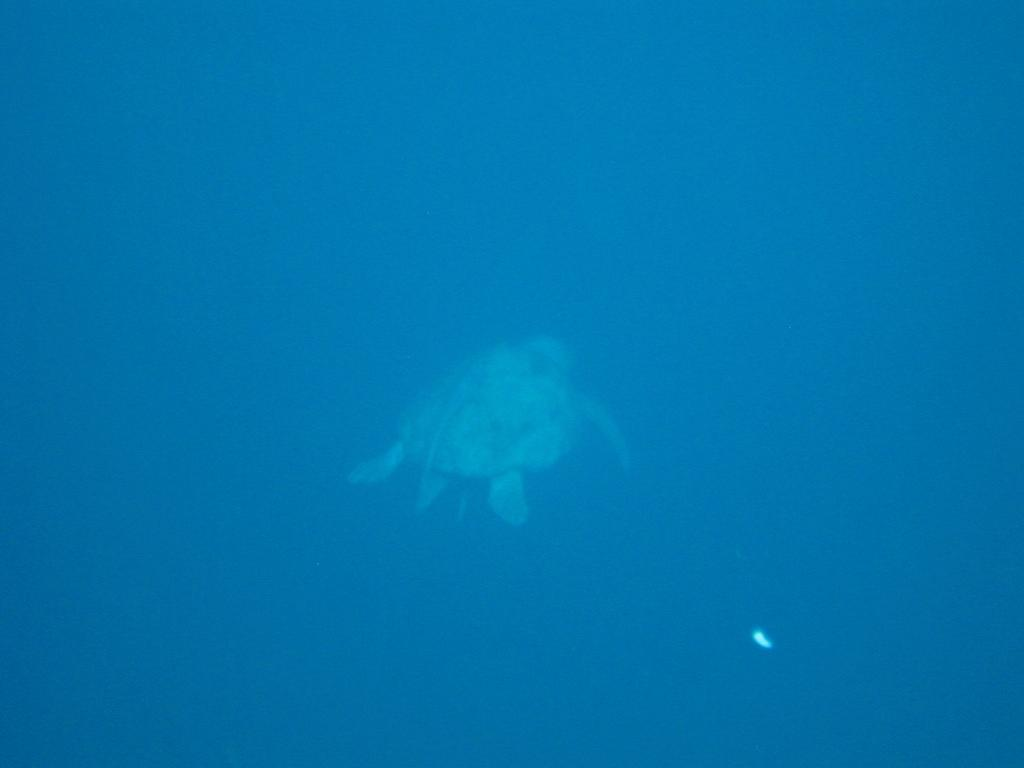What type of animal is in the water in the image? There is a tortoise in the water in the image. What type of map can be seen in the image? There is no map present in the image; it features a tortoise in the water. What type of butter is visible on the tortoise's shell in the image? There is no butter present in the image; it features a tortoise in the water. 